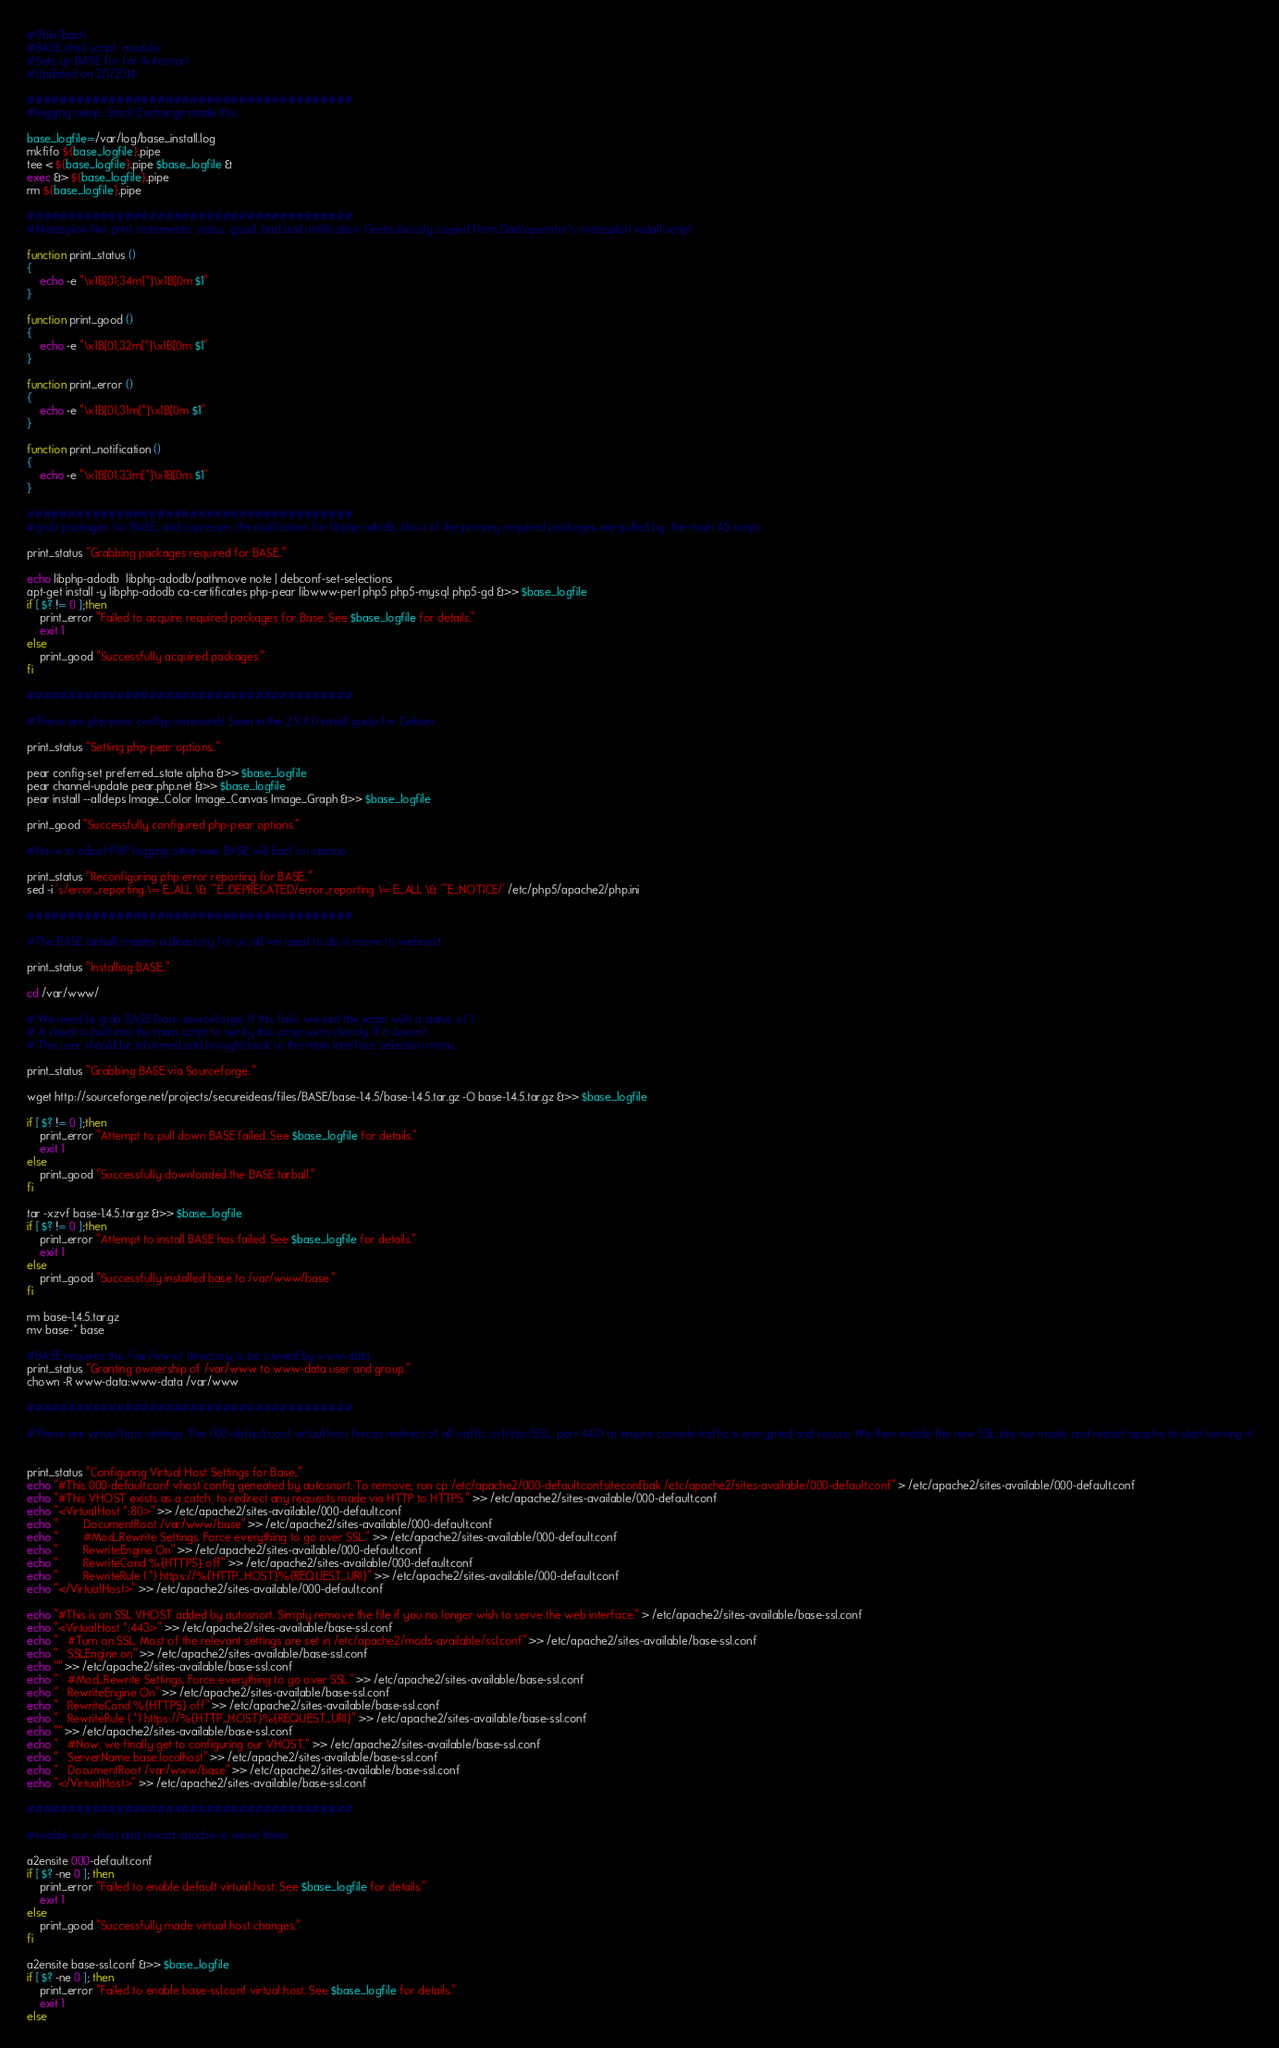Convert code to text. <code><loc_0><loc_0><loc_500><loc_500><_Bash_>#!/bin/bash
#BASE shell script 'module'
#Sets up BASE for for Autosnort
#Updated on 2/1/2014

########################################
#logging setup: Stack Exchange made this.

base_logfile=/var/log/base_install.log
mkfifo ${base_logfile}.pipe
tee < ${base_logfile}.pipe $base_logfile &
exec &> ${base_logfile}.pipe
rm ${base_logfile}.pipe

########################################
#Metasploit-like print statements: status, good, bad and notification. Gratouitiously copied from Darkoperator's metasploit install script.

function print_status ()
{
    echo -e "\x1B[01;34m[*]\x1B[0m $1"
}

function print_good ()
{
    echo -e "\x1B[01;32m[*]\x1B[0m $1"
}

function print_error ()
{
    echo -e "\x1B[01;31m[*]\x1B[0m $1"
}

function print_notification ()
{
	echo -e "\x1B[01;33m[*]\x1B[0m $1"
}

########################################
#grab packages for BASE, and supresses the notification for libphp-adodb. Most of the primary required packages are pulled by  the main AS script.

print_status "Grabbing packages required for BASE.."

echo libphp-adodb  libphp-adodb/pathmove note | debconf-set-selections
apt-get install -y libphp-adodb ca-certificates php-pear libwww-perl php5 php5-mysql php5-gd &>> $base_logfile
if [ $? != 0 ];then
	print_error "Failed to acquire required packages for Base. See $base_logfile for details."
	exit 1
else
	print_good "Successfully acquired packages."
fi

########################################

#These are php-pear config commands Seen in the 2.9.4.0 install guide for Debian.

print_status "Setting php-pear options.."

pear config-set preferred_state alpha &>> $base_logfile
pear channel-update pear.php.net &>> $base_logfile
pear install --alldeps Image_Color Image_Canvas Image_Graph &>> $base_logfile

print_good "Successfully configured php-pear options."

#Have to adjust PHP logging otherwise BASE will barf on startup.

print_status "Reconfiguring php error reporting for BASE.."
sed -i 's/error_reporting \= E_ALL \& ~E_DEPRECATED/error_reporting \= E_ALL \& ~E_NOTICE/' /etc/php5/apache2/php.ini

########################################

#The BASE tarball creates a directory for us, all we need to do is move to webroot.

print_status "Installing BASE.."

cd /var/www/

# We need to grab BASE from sourceforge. If this fails, we exit the script with a status of 1
# A check is built into the main script to verify this script exits cleanly. If it doesn't,
# The user should be informed and brought back to the main interface selection menu.

print_status "Grabbing BASE via Sourceforge.."

wget http://sourceforge.net/projects/secureideas/files/BASE/base-1.4.5/base-1.4.5.tar.gz -O base-1.4.5.tar.gz &>> $base_logfile
 
if [ $? != 0 ];then
	print_error "Attempt to pull down BASE failed. See $base_logfile for details."
	exit 1
else
	print_good "Successfully downloaded the BASE tarball."
fi

tar -xzvf base-1.4.5.tar.gz &>> $base_logfile
if [ $? != 0 ];then
	print_error "Attempt to install BASE has failed. See $base_logfile for details."
	exit 1
else
	print_good "Successfully installed base to /var/www/base."
fi

rm base-1.4.5.tar.gz
mv base-* base

#BASE requires the /var/www/ directory to be owned by www-data
print_status "Granting ownership of /var/www to www-data user and group."
chown -R www-data:www-data /var/www

########################################

#These are virtual host settings. The 000-default.conf virtual host forces redirect of all traffic to https (SSL, port 443) to ensure console traffic is encrypted and secure. We then enable the new SSL site we made, and restart apache to start serving it.


print_status "Configuring Virtual Host Settings for Base.."
echo "#This 000-default.conf vhost config geneated by autosnort. To remove, run cp /etc/apache2/000-default.confsiteconfbak /etc/apache2/sites-available/000-default.conf" > /etc/apache2/sites-available/000-default.conf
echo "#This VHOST exists as a catch, to redirect any requests made via HTTP to HTTPS." >> /etc/apache2/sites-available/000-default.conf
echo "<VirtualHost *:80>" >> /etc/apache2/sites-available/000-default.conf
echo "        DocumentRoot /var/www/base" >> /etc/apache2/sites-available/000-default.conf
echo "        #Mod_Rewrite Settings. Force everything to go over SSL." >> /etc/apache2/sites-available/000-default.conf
echo "        RewriteEngine On" >> /etc/apache2/sites-available/000-default.conf
echo "        RewriteCond %{HTTPS} off" >> /etc/apache2/sites-available/000-default.conf
echo "        RewriteRule (.*) https://%{HTTP_HOST}%{REQUEST_URI}" >> /etc/apache2/sites-available/000-default.conf
echo "</VirtualHost>" >> /etc/apache2/sites-available/000-default.conf

echo "#This is an SSL VHOST added by autosnort. Simply remove the file if you no longer wish to serve the web interface." > /etc/apache2/sites-available/base-ssl.conf
echo "<VirtualHost *:443>" >> /etc/apache2/sites-available/base-ssl.conf
echo "	#Turn on SSL. Most of the relevant settings are set in /etc/apache2/mods-available/ssl.conf" >> /etc/apache2/sites-available/base-ssl.conf
echo "	SSLEngine on" >> /etc/apache2/sites-available/base-ssl.conf
echo "" >> /etc/apache2/sites-available/base-ssl.conf
echo "	#Mod_Rewrite Settings. Force everything to go over SSL." >> /etc/apache2/sites-available/base-ssl.conf
echo "	RewriteEngine On" >> /etc/apache2/sites-available/base-ssl.conf
echo "	RewriteCond %{HTTPS} off" >> /etc/apache2/sites-available/base-ssl.conf
echo "	RewriteRule (.*) https://%{HTTP_HOST}%{REQUEST_URI}" >> /etc/apache2/sites-available/base-ssl.conf
echo "" >> /etc/apache2/sites-available/base-ssl.conf
echo "	#Now, we finally get to configuring our VHOST." >> /etc/apache2/sites-available/base-ssl.conf
echo "	ServerName base.localhost" >> /etc/apache2/sites-available/base-ssl.conf
echo "	DocumentRoot /var/www/base" >> /etc/apache2/sites-available/base-ssl.conf
echo "</VirtualHost>" >> /etc/apache2/sites-available/base-ssl.conf

########################################

#enable our vhost and restart apache to serve them.

a2ensite 000-default.conf
if [ $? -ne 0 ]; then
    print_error "Failed to enable default virtual host. See $base_logfile for details."
	exit 1	
else
    print_good "Successfully made virtual host changes."
fi

a2ensite base-ssl.conf &>> $base_logfile
if [ $? -ne 0 ]; then
    print_error "Failed to enable base-ssl.conf virtual host. See $base_logfile for details."
	exit 1	
else</code> 